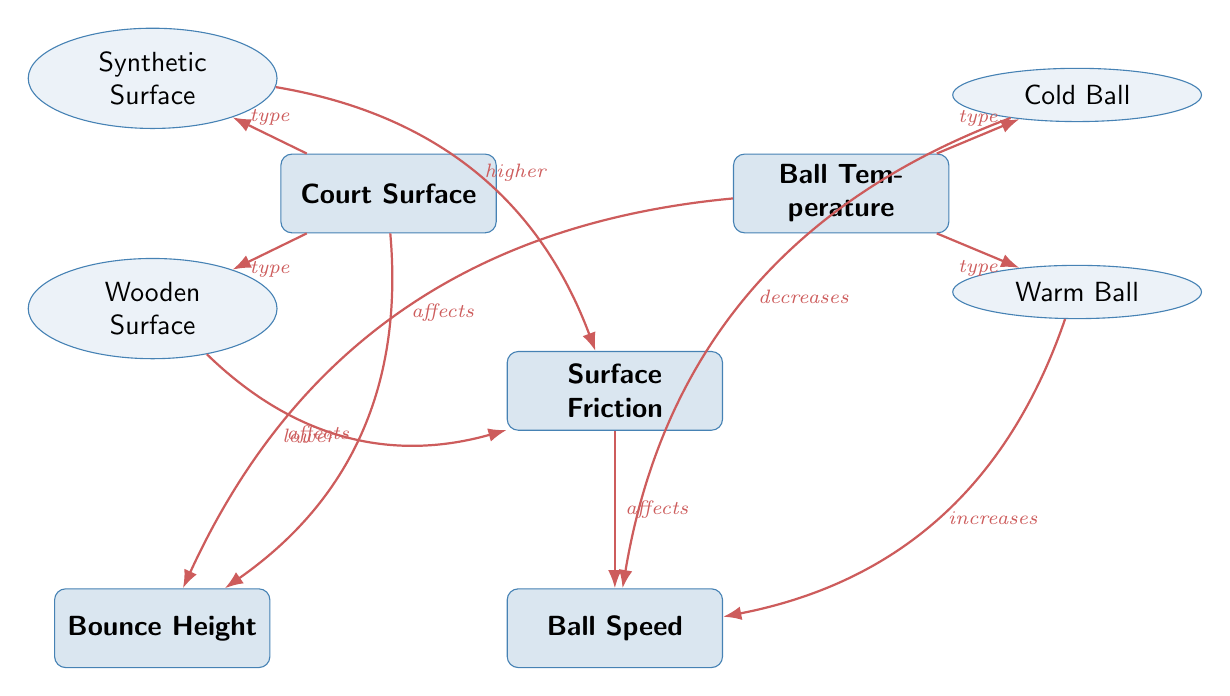What are the two types of court surfaces mentioned? The diagram specifically lists "Synthetic Surface" and "Wooden Surface" as the two types of court surfaces. Both are directly connected to the "Court Surface" node, showing they are classifications under that category.
Answer: Synthetic Surface, Wooden Surface How does a warm ball affect ball speed? According to the diagram, a warm ball "increases" ball speed. The arrow pointing from "Warm Ball" to "Ball Speed" clearly indicates this relationship.
Answer: increases What effect does a wooden surface have on surface friction? The diagram shows that a wooden surface has "lower" friction. This is indicated by the arrow pointing from "Wooden Surface" to "Surface Friction," labeled with "lower."
Answer: lower Which type of ball temperature has a direct connection with bounce height? The diagram indicates that both "Cold Ball" and "Warm Ball" have arrows leading to "Bounce Height." Therefore, both temperature types directly influence bounce height, but the specific connection identified states that ball temperature "affects" bounce height.
Answer: Ball Temperature How does surface friction influence ball speed? The diagram depicts an arrow from "Surface Friction" pointing to "Ball Speed," with the label "affects." This implies that the amount of friction on the court surface will directly influence how fast the ball can move.
Answer: affects 